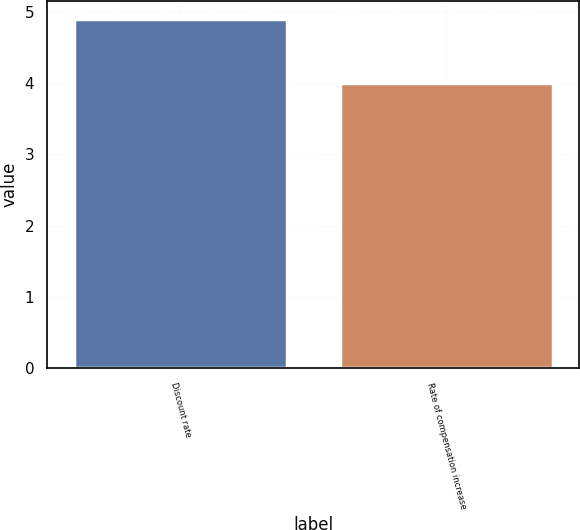<chart> <loc_0><loc_0><loc_500><loc_500><bar_chart><fcel>Discount rate<fcel>Rate of compensation increase<nl><fcel>4.9<fcel>4<nl></chart> 